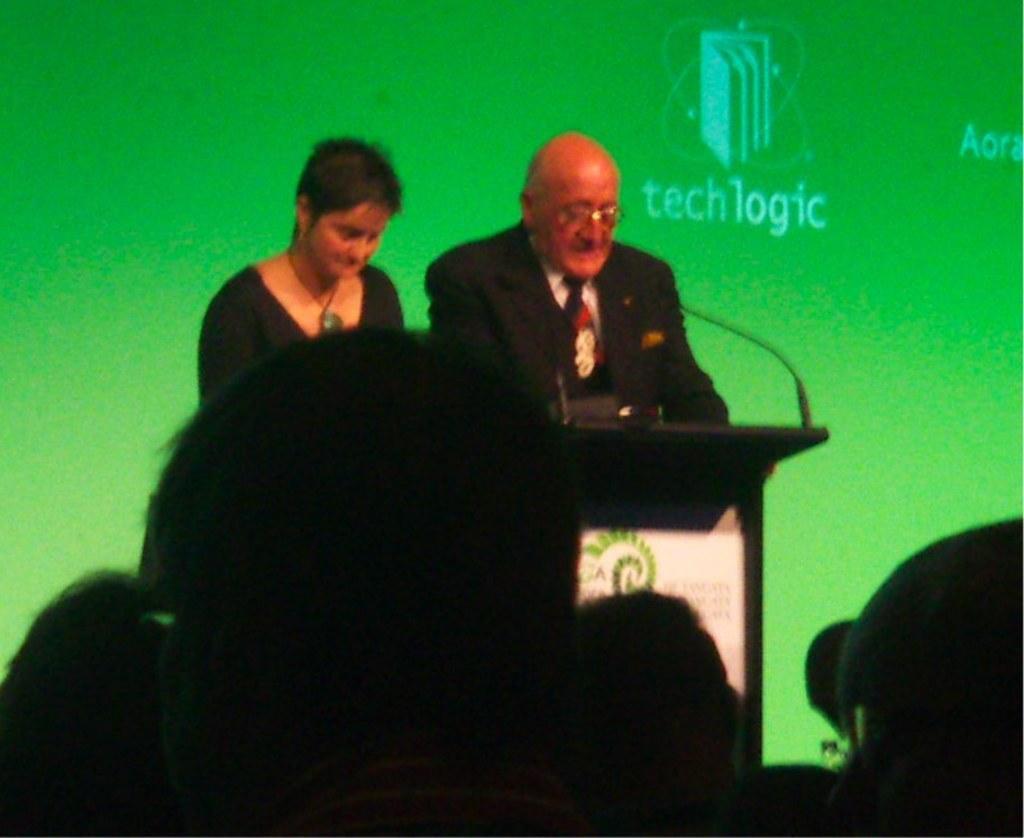Describe this image in one or two sentences. There is a person in black color suit standing in front of a stand on which, there is a mic near a woman who is standing on the stage. In front of them, there are persons standing on chairs. In the background, there is a screen which is in green color. 